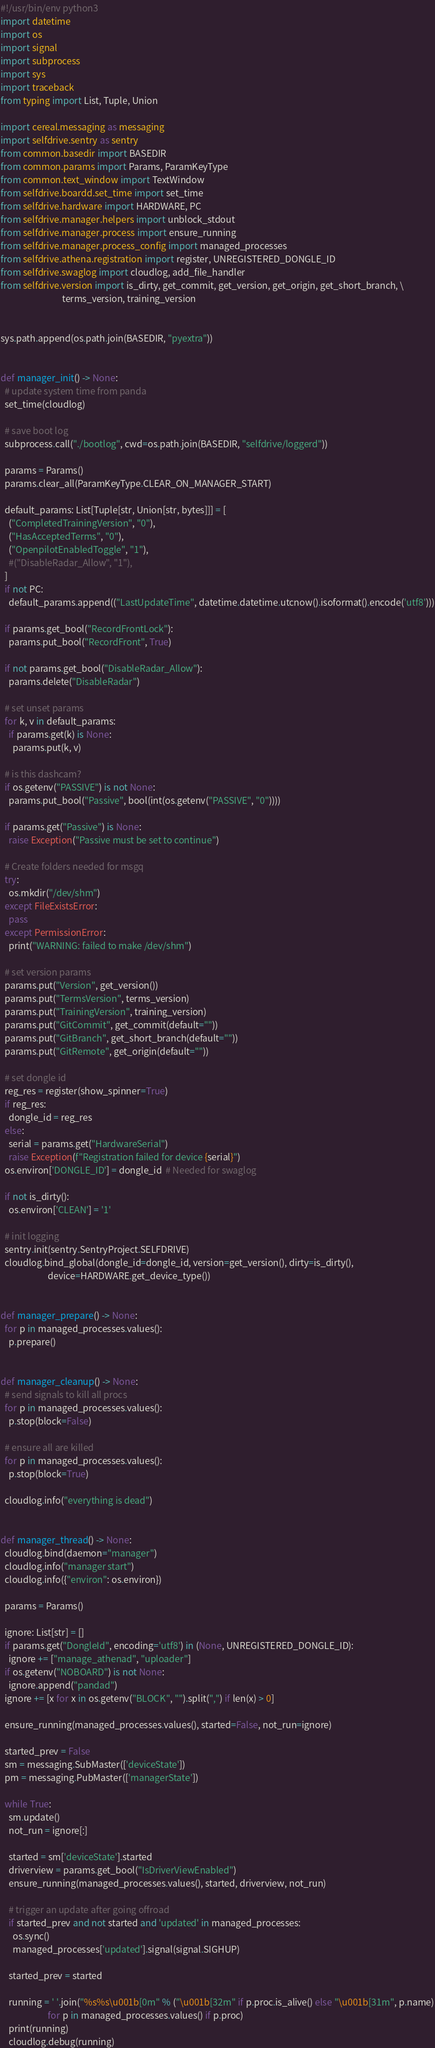Convert code to text. <code><loc_0><loc_0><loc_500><loc_500><_Python_>#!/usr/bin/env python3
import datetime
import os
import signal
import subprocess
import sys
import traceback
from typing import List, Tuple, Union

import cereal.messaging as messaging
import selfdrive.sentry as sentry
from common.basedir import BASEDIR
from common.params import Params, ParamKeyType
from common.text_window import TextWindow
from selfdrive.boardd.set_time import set_time
from selfdrive.hardware import HARDWARE, PC
from selfdrive.manager.helpers import unblock_stdout
from selfdrive.manager.process import ensure_running
from selfdrive.manager.process_config import managed_processes
from selfdrive.athena.registration import register, UNREGISTERED_DONGLE_ID
from selfdrive.swaglog import cloudlog, add_file_handler
from selfdrive.version import is_dirty, get_commit, get_version, get_origin, get_short_branch, \
                              terms_version, training_version


sys.path.append(os.path.join(BASEDIR, "pyextra"))


def manager_init() -> None:
  # update system time from panda
  set_time(cloudlog)

  # save boot log
  subprocess.call("./bootlog", cwd=os.path.join(BASEDIR, "selfdrive/loggerd"))

  params = Params()
  params.clear_all(ParamKeyType.CLEAR_ON_MANAGER_START)

  default_params: List[Tuple[str, Union[str, bytes]]] = [
    ("CompletedTrainingVersion", "0"),
    ("HasAcceptedTerms", "0"),
    ("OpenpilotEnabledToggle", "1"),
    #("DisableRadar_Allow", "1"),
  ]
  if not PC:
    default_params.append(("LastUpdateTime", datetime.datetime.utcnow().isoformat().encode('utf8')))

  if params.get_bool("RecordFrontLock"):
    params.put_bool("RecordFront", True)

  if not params.get_bool("DisableRadar_Allow"):
    params.delete("DisableRadar")

  # set unset params
  for k, v in default_params:
    if params.get(k) is None:
      params.put(k, v)

  # is this dashcam?
  if os.getenv("PASSIVE") is not None:
    params.put_bool("Passive", bool(int(os.getenv("PASSIVE", "0"))))

  if params.get("Passive") is None:
    raise Exception("Passive must be set to continue")

  # Create folders needed for msgq
  try:
    os.mkdir("/dev/shm")
  except FileExistsError:
    pass
  except PermissionError:
    print("WARNING: failed to make /dev/shm")

  # set version params
  params.put("Version", get_version())
  params.put("TermsVersion", terms_version)
  params.put("TrainingVersion", training_version)
  params.put("GitCommit", get_commit(default=""))
  params.put("GitBranch", get_short_branch(default=""))
  params.put("GitRemote", get_origin(default=""))

  # set dongle id
  reg_res = register(show_spinner=True)
  if reg_res:
    dongle_id = reg_res
  else:
    serial = params.get("HardwareSerial")
    raise Exception(f"Registration failed for device {serial}")
  os.environ['DONGLE_ID'] = dongle_id  # Needed for swaglog

  if not is_dirty():
    os.environ['CLEAN'] = '1'

  # init logging
  sentry.init(sentry.SentryProject.SELFDRIVE)
  cloudlog.bind_global(dongle_id=dongle_id, version=get_version(), dirty=is_dirty(),
                       device=HARDWARE.get_device_type())


def manager_prepare() -> None:
  for p in managed_processes.values():
    p.prepare()


def manager_cleanup() -> None:
  # send signals to kill all procs
  for p in managed_processes.values():
    p.stop(block=False)

  # ensure all are killed
  for p in managed_processes.values():
    p.stop(block=True)

  cloudlog.info("everything is dead")


def manager_thread() -> None:
  cloudlog.bind(daemon="manager")
  cloudlog.info("manager start")
  cloudlog.info({"environ": os.environ})

  params = Params()

  ignore: List[str] = []
  if params.get("DongleId", encoding='utf8') in (None, UNREGISTERED_DONGLE_ID):
    ignore += ["manage_athenad", "uploader"]
  if os.getenv("NOBOARD") is not None:
    ignore.append("pandad")
  ignore += [x for x in os.getenv("BLOCK", "").split(",") if len(x) > 0]

  ensure_running(managed_processes.values(), started=False, not_run=ignore)

  started_prev = False
  sm = messaging.SubMaster(['deviceState'])
  pm = messaging.PubMaster(['managerState'])

  while True:
    sm.update()
    not_run = ignore[:]

    started = sm['deviceState'].started
    driverview = params.get_bool("IsDriverViewEnabled")
    ensure_running(managed_processes.values(), started, driverview, not_run)

    # trigger an update after going offroad
    if started_prev and not started and 'updated' in managed_processes:
      os.sync()
      managed_processes['updated'].signal(signal.SIGHUP)

    started_prev = started

    running = ' '.join("%s%s\u001b[0m" % ("\u001b[32m" if p.proc.is_alive() else "\u001b[31m", p.name)
                       for p in managed_processes.values() if p.proc)
    print(running)
    cloudlog.debug(running)
</code> 